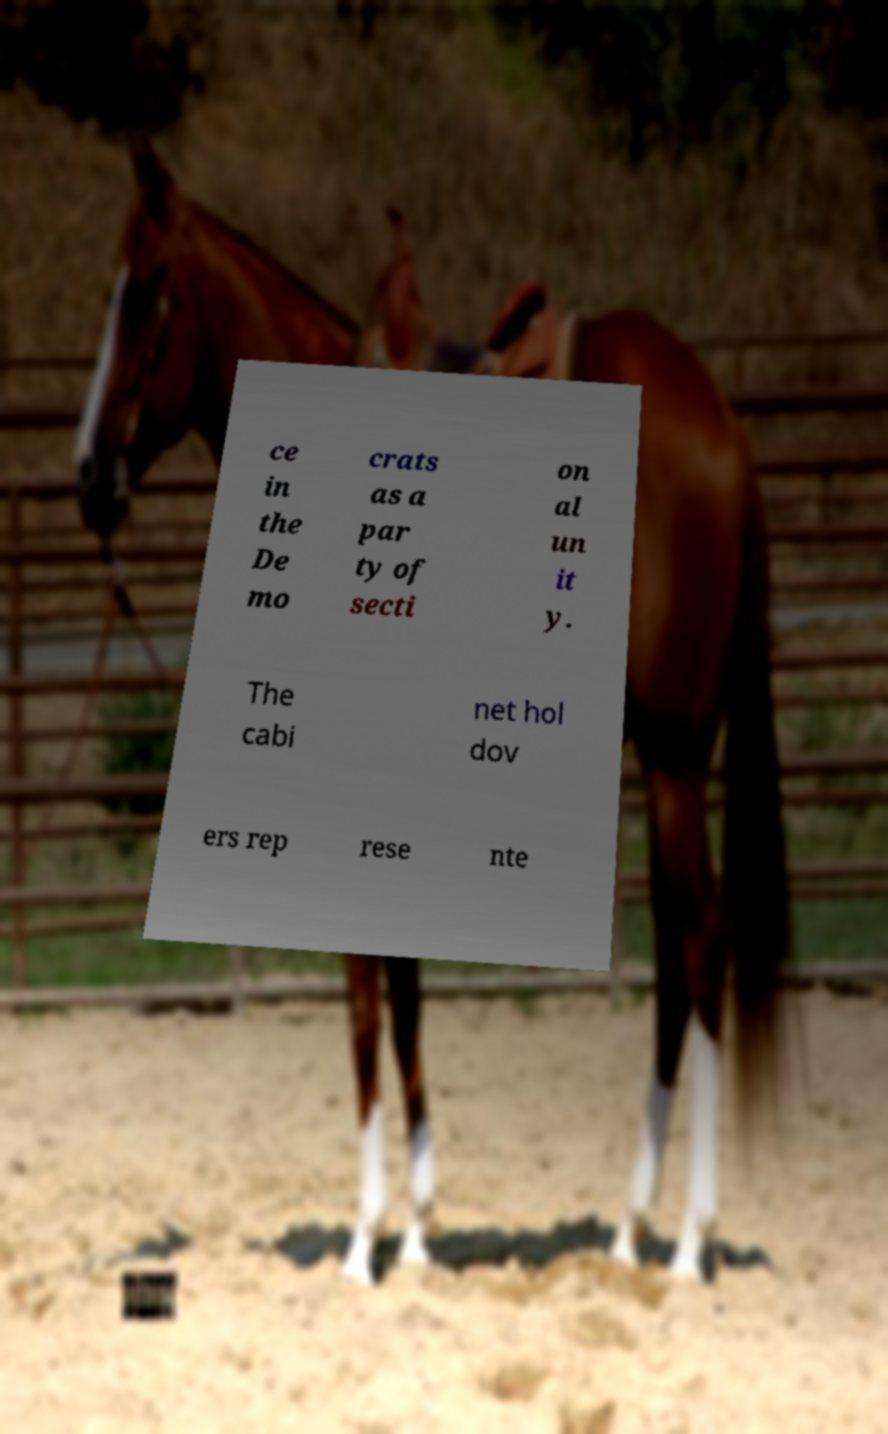There's text embedded in this image that I need extracted. Can you transcribe it verbatim? ce in the De mo crats as a par ty of secti on al un it y. The cabi net hol dov ers rep rese nte 